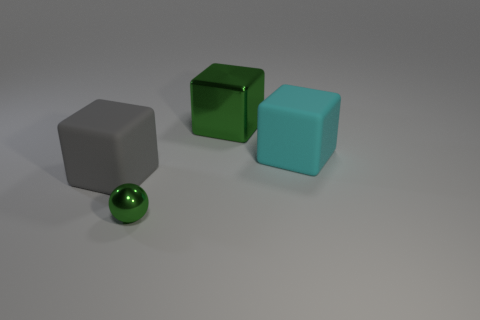Subtract all purple spheres. Subtract all brown blocks. How many spheres are left? 1 Add 1 cyan rubber blocks. How many objects exist? 5 Subtract all cubes. How many objects are left? 1 Subtract 0 brown spheres. How many objects are left? 4 Subtract all tiny matte things. Subtract all big cubes. How many objects are left? 1 Add 3 cyan matte objects. How many cyan matte objects are left? 4 Add 3 cyan things. How many cyan things exist? 4 